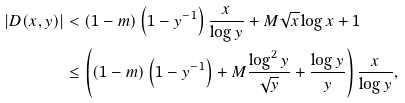Convert formula to latex. <formula><loc_0><loc_0><loc_500><loc_500>| D ( x , y ) | & < ( 1 - m ) \left ( 1 - y ^ { - 1 } \right ) \frac { x } { \log y } + M \sqrt { x } \log x + 1 \\ & \leq \left ( ( 1 - m ) \left ( 1 - y ^ { - 1 } \right ) + M \frac { \log ^ { 2 } y } { \sqrt { y } } + \frac { \log y } { y } \right ) \frac { x } { \log y } ,</formula> 